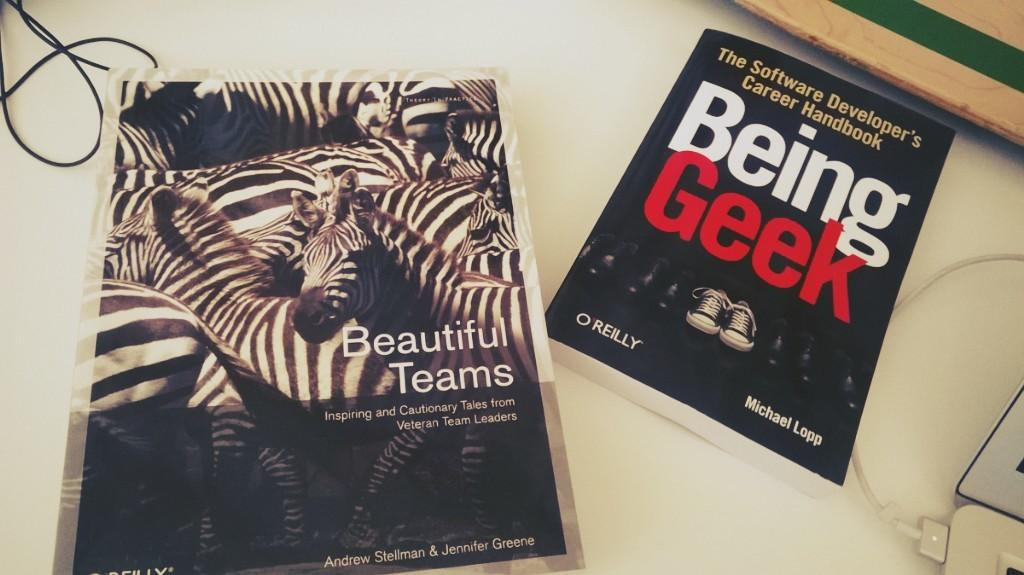<image>
Present a compact description of the photo's key features. two books include Beautiful Teams and Being Geek on a table 